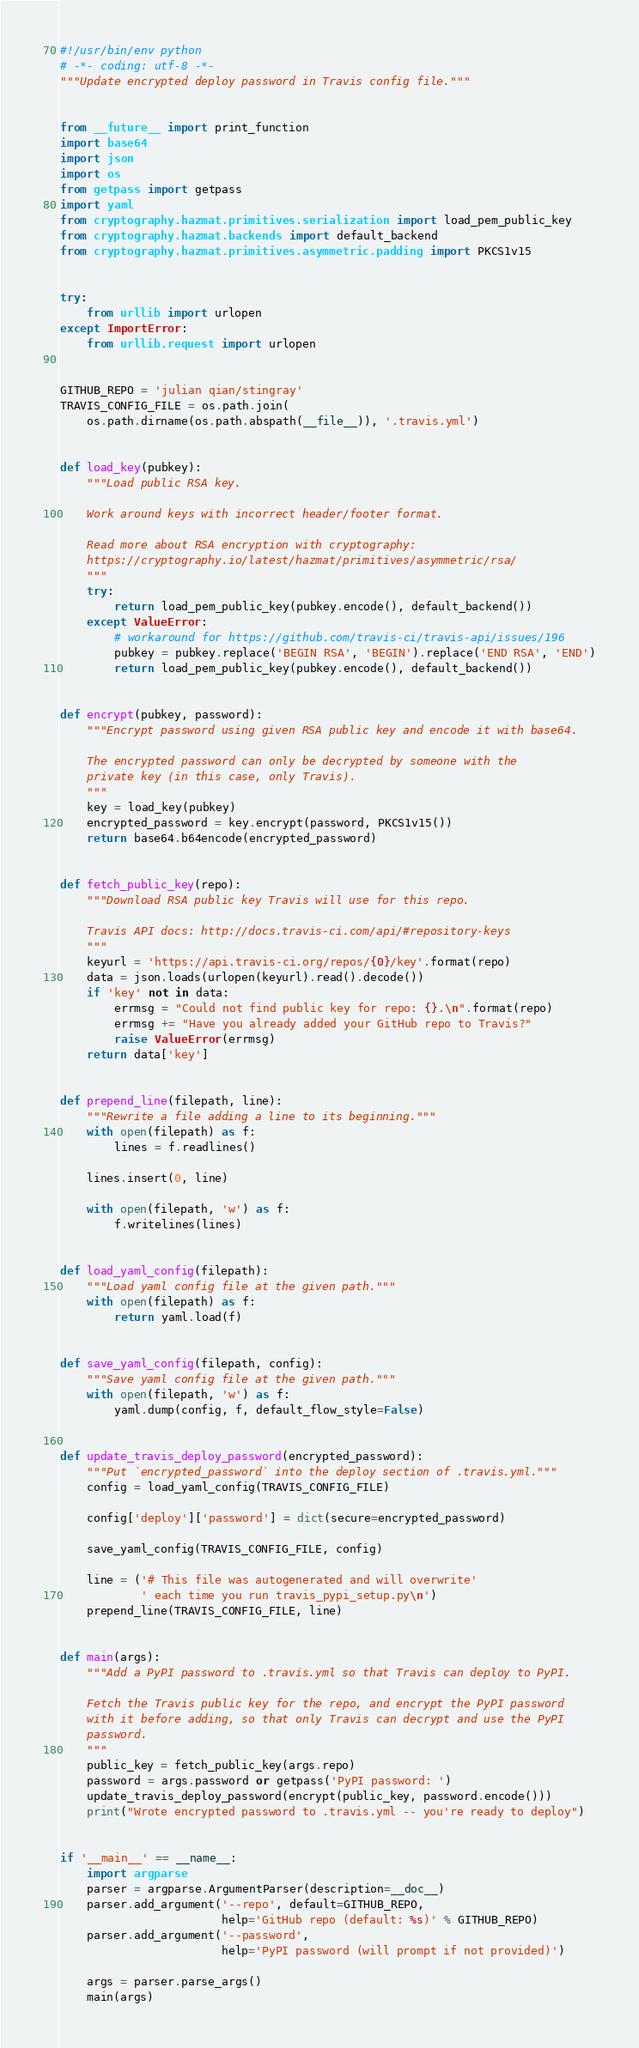<code> <loc_0><loc_0><loc_500><loc_500><_Python_>#!/usr/bin/env python
# -*- coding: utf-8 -*-
"""Update encrypted deploy password in Travis config file."""


from __future__ import print_function
import base64
import json
import os
from getpass import getpass
import yaml
from cryptography.hazmat.primitives.serialization import load_pem_public_key
from cryptography.hazmat.backends import default_backend
from cryptography.hazmat.primitives.asymmetric.padding import PKCS1v15


try:
    from urllib import urlopen
except ImportError:
    from urllib.request import urlopen


GITHUB_REPO = 'julian qian/stingray'
TRAVIS_CONFIG_FILE = os.path.join(
    os.path.dirname(os.path.abspath(__file__)), '.travis.yml')


def load_key(pubkey):
    """Load public RSA key.

    Work around keys with incorrect header/footer format.

    Read more about RSA encryption with cryptography:
    https://cryptography.io/latest/hazmat/primitives/asymmetric/rsa/
    """
    try:
        return load_pem_public_key(pubkey.encode(), default_backend())
    except ValueError:
        # workaround for https://github.com/travis-ci/travis-api/issues/196
        pubkey = pubkey.replace('BEGIN RSA', 'BEGIN').replace('END RSA', 'END')
        return load_pem_public_key(pubkey.encode(), default_backend())


def encrypt(pubkey, password):
    """Encrypt password using given RSA public key and encode it with base64.

    The encrypted password can only be decrypted by someone with the
    private key (in this case, only Travis).
    """
    key = load_key(pubkey)
    encrypted_password = key.encrypt(password, PKCS1v15())
    return base64.b64encode(encrypted_password)


def fetch_public_key(repo):
    """Download RSA public key Travis will use for this repo.

    Travis API docs: http://docs.travis-ci.com/api/#repository-keys
    """
    keyurl = 'https://api.travis-ci.org/repos/{0}/key'.format(repo)
    data = json.loads(urlopen(keyurl).read().decode())
    if 'key' not in data:
        errmsg = "Could not find public key for repo: {}.\n".format(repo)
        errmsg += "Have you already added your GitHub repo to Travis?"
        raise ValueError(errmsg)
    return data['key']


def prepend_line(filepath, line):
    """Rewrite a file adding a line to its beginning."""
    with open(filepath) as f:
        lines = f.readlines()

    lines.insert(0, line)

    with open(filepath, 'w') as f:
        f.writelines(lines)


def load_yaml_config(filepath):
    """Load yaml config file at the given path."""
    with open(filepath) as f:
        return yaml.load(f)


def save_yaml_config(filepath, config):
    """Save yaml config file at the given path."""
    with open(filepath, 'w') as f:
        yaml.dump(config, f, default_flow_style=False)


def update_travis_deploy_password(encrypted_password):
    """Put `encrypted_password` into the deploy section of .travis.yml."""
    config = load_yaml_config(TRAVIS_CONFIG_FILE)

    config['deploy']['password'] = dict(secure=encrypted_password)

    save_yaml_config(TRAVIS_CONFIG_FILE, config)

    line = ('# This file was autogenerated and will overwrite'
            ' each time you run travis_pypi_setup.py\n')
    prepend_line(TRAVIS_CONFIG_FILE, line)


def main(args):
    """Add a PyPI password to .travis.yml so that Travis can deploy to PyPI.

    Fetch the Travis public key for the repo, and encrypt the PyPI password
    with it before adding, so that only Travis can decrypt and use the PyPI
    password.
    """
    public_key = fetch_public_key(args.repo)
    password = args.password or getpass('PyPI password: ')
    update_travis_deploy_password(encrypt(public_key, password.encode()))
    print("Wrote encrypted password to .travis.yml -- you're ready to deploy")


if '__main__' == __name__:
    import argparse
    parser = argparse.ArgumentParser(description=__doc__)
    parser.add_argument('--repo', default=GITHUB_REPO,
                        help='GitHub repo (default: %s)' % GITHUB_REPO)
    parser.add_argument('--password',
                        help='PyPI password (will prompt if not provided)')

    args = parser.parse_args()
    main(args)
</code> 